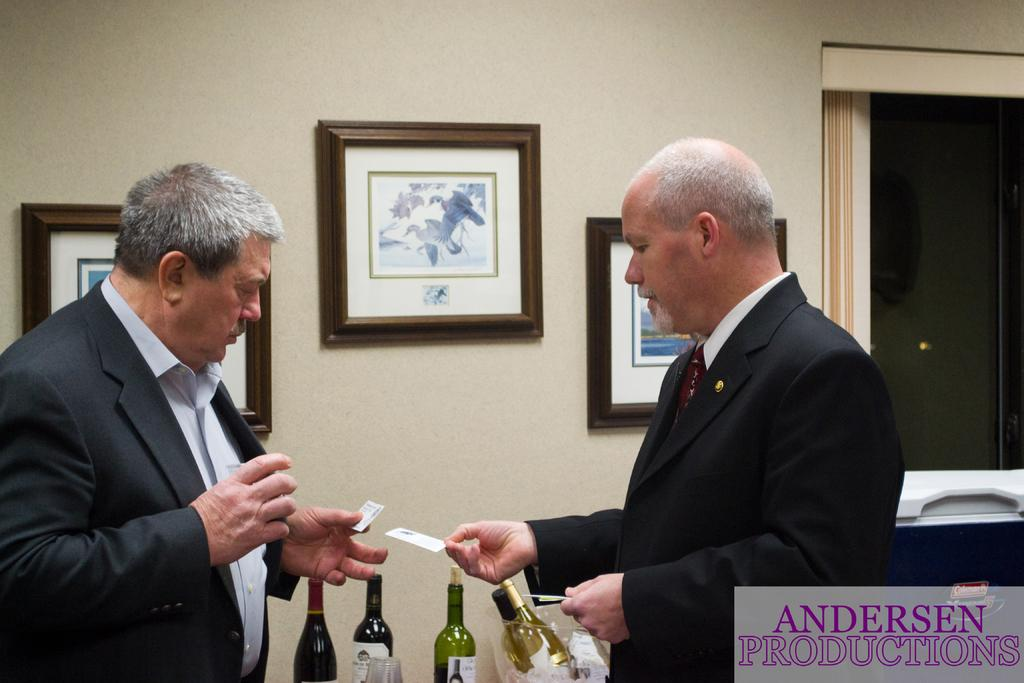How many persons are visible in the image? There are persons in the image, but the exact number cannot be determined from the provided facts. What type of objects can be seen in the image? There are bottles, a name board, and other objects visible in the image. What can be seen in the background of the image? There is a wall, frames, and other objects in the background of the image. What type of honey is being poured from the tin in the image? There is no honey or tin present in the image. Can you describe the flame coming from the bottle in the image? There is no flame present in the image; the facts do not mention any fire or heat source. 